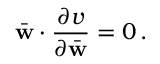<formula> <loc_0><loc_0><loc_500><loc_500>\bar { w } \cdot \frac { \partial v } { \partial \bar { w } } = 0 \, .</formula> 